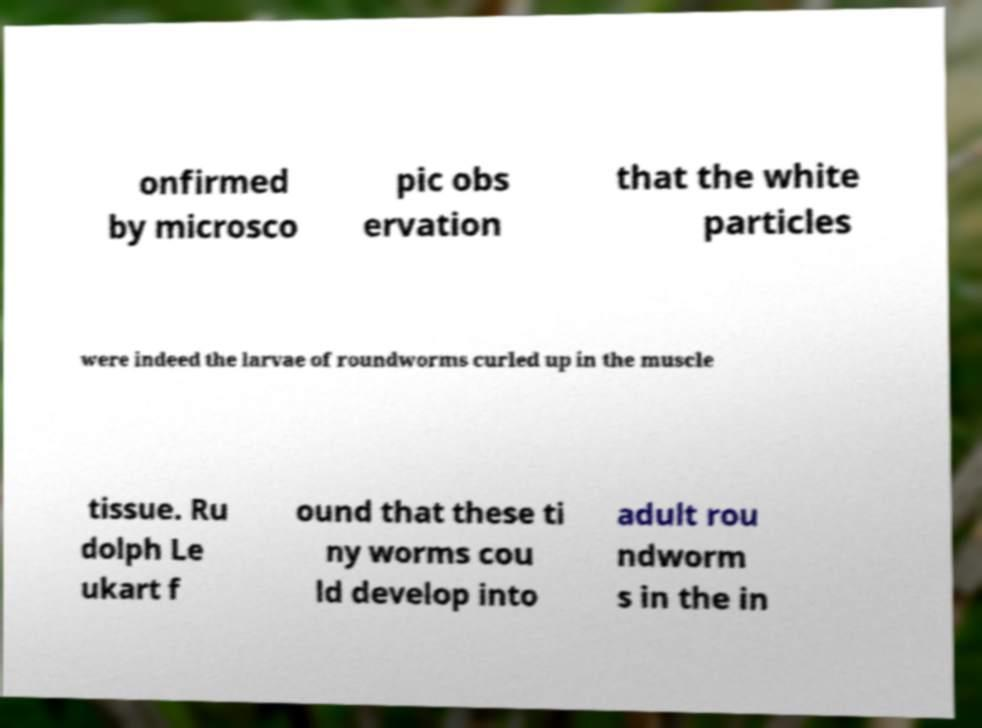I need the written content from this picture converted into text. Can you do that? onfirmed by microsco pic obs ervation that the white particles were indeed the larvae of roundworms curled up in the muscle tissue. Ru dolph Le ukart f ound that these ti ny worms cou ld develop into adult rou ndworm s in the in 